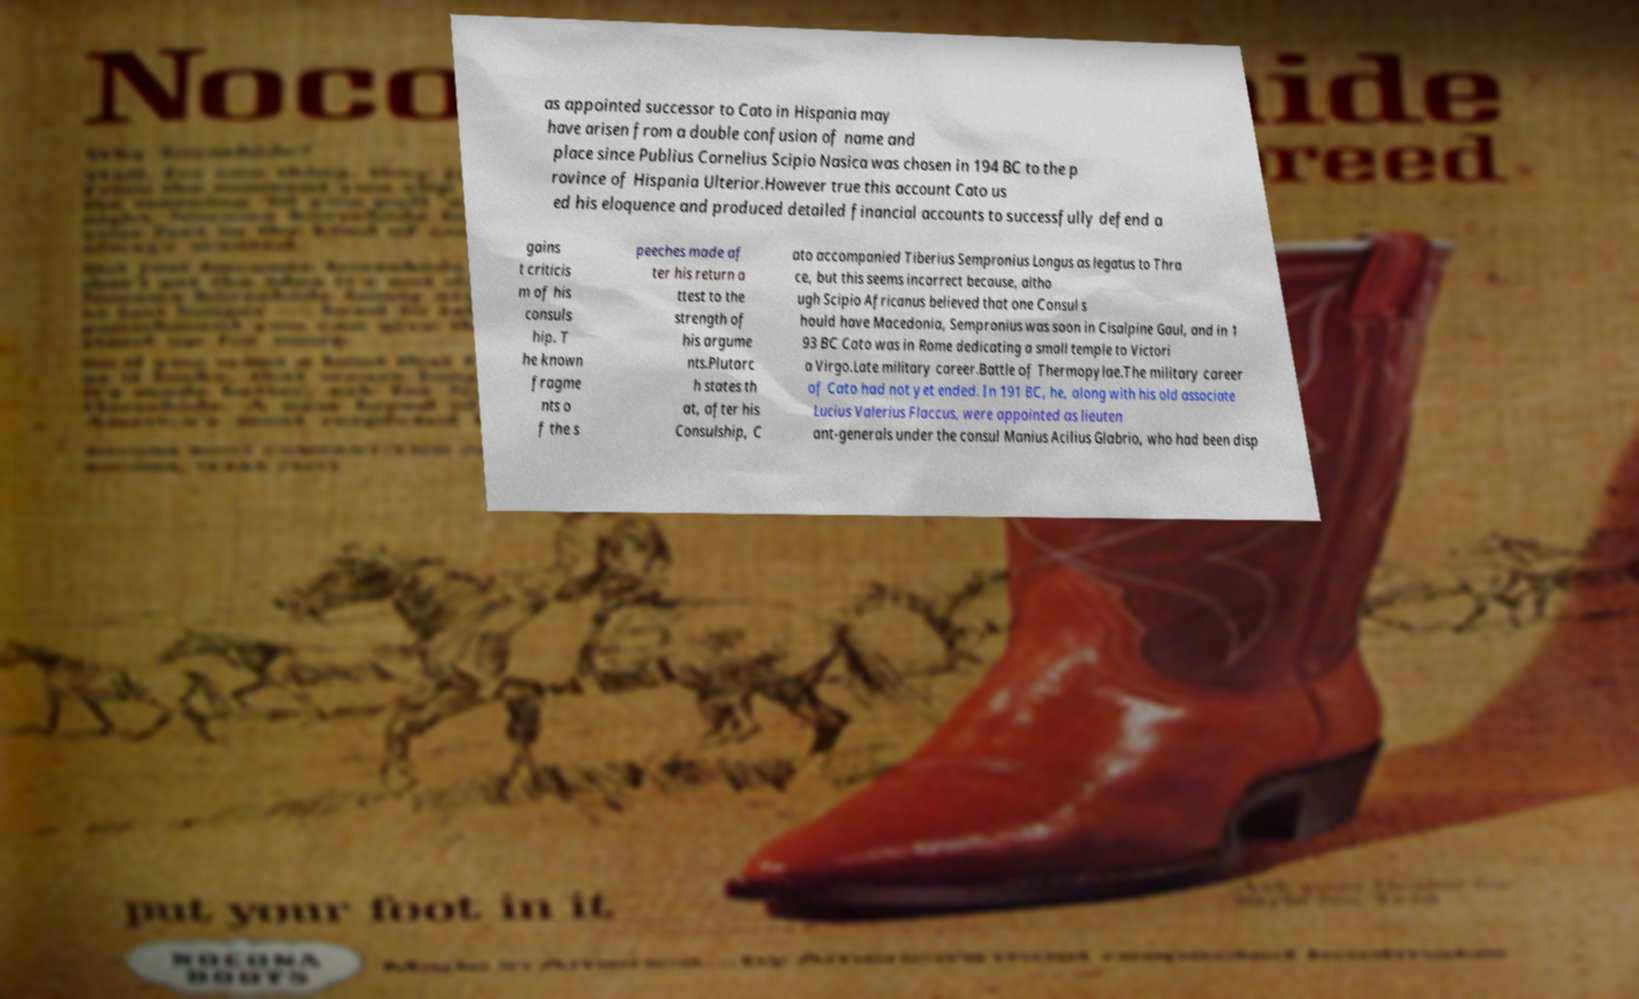For documentation purposes, I need the text within this image transcribed. Could you provide that? as appointed successor to Cato in Hispania may have arisen from a double confusion of name and place since Publius Cornelius Scipio Nasica was chosen in 194 BC to the p rovince of Hispania Ulterior.However true this account Cato us ed his eloquence and produced detailed financial accounts to successfully defend a gains t criticis m of his consuls hip. T he known fragme nts o f the s peeches made af ter his return a ttest to the strength of his argume nts.Plutarc h states th at, after his Consulship, C ato accompanied Tiberius Sempronius Longus as legatus to Thra ce, but this seems incorrect because, altho ugh Scipio Africanus believed that one Consul s hould have Macedonia, Sempronius was soon in Cisalpine Gaul, and in 1 93 BC Cato was in Rome dedicating a small temple to Victori a Virgo.Late military career.Battle of Thermopylae.The military career of Cato had not yet ended. In 191 BC, he, along with his old associate Lucius Valerius Flaccus, were appointed as lieuten ant-generals under the consul Manius Acilius Glabrio, who had been disp 